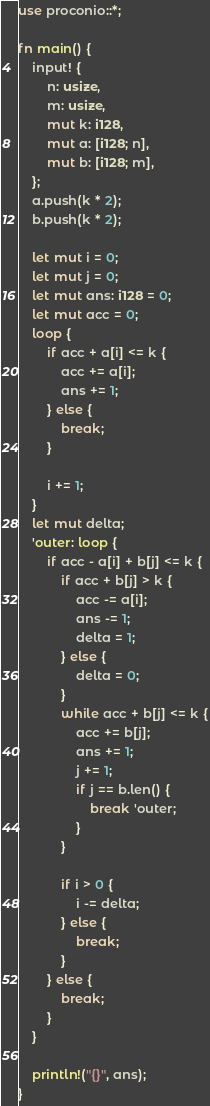Convert code to text. <code><loc_0><loc_0><loc_500><loc_500><_Rust_>use proconio::*;

fn main() {
    input! {
        n: usize,
        m: usize,
        mut k: i128,
        mut a: [i128; n],
        mut b: [i128; m],
    };
    a.push(k * 2);
    b.push(k * 2);

    let mut i = 0;
    let mut j = 0;
    let mut ans: i128 = 0;
    let mut acc = 0;
    loop {
        if acc + a[i] <= k {
            acc += a[i];
            ans += 1;
        } else {
            break;
        }

        i += 1;
    }
    let mut delta;
    'outer: loop {
        if acc - a[i] + b[j] <= k {
            if acc + b[j] > k {
                acc -= a[i];
                ans -= 1;
                delta = 1;
            } else {
                delta = 0;
            }
            while acc + b[j] <= k {
                acc += b[j];
                ans += 1;
                j += 1;
                if j == b.len() {
                    break 'outer;
                }
            }

            if i > 0 {
                i -= delta;
            } else {
                break;
            }
        } else {
            break;
        }
    }

    println!("{}", ans);
}
</code> 